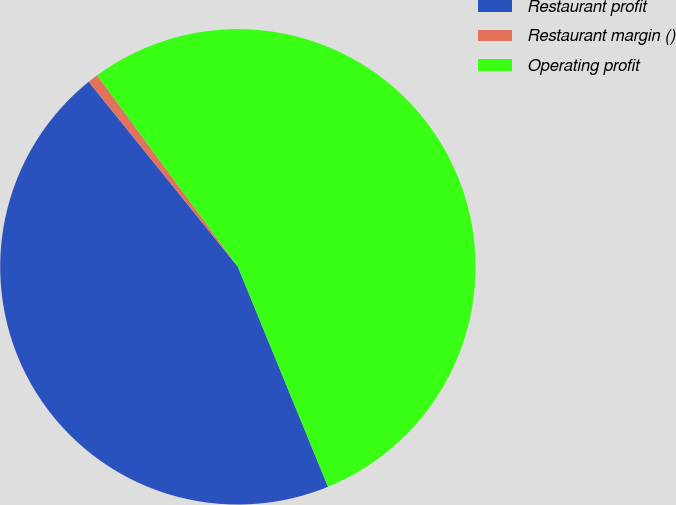Convert chart. <chart><loc_0><loc_0><loc_500><loc_500><pie_chart><fcel>Restaurant profit<fcel>Restaurant margin ()<fcel>Operating profit<nl><fcel>45.39%<fcel>0.71%<fcel>53.9%<nl></chart> 